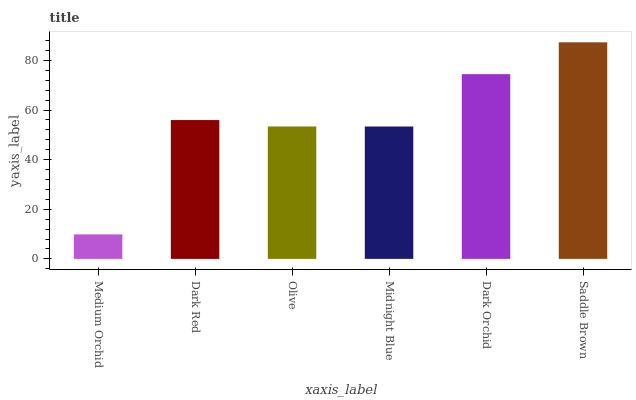Is Medium Orchid the minimum?
Answer yes or no. Yes. Is Saddle Brown the maximum?
Answer yes or no. Yes. Is Dark Red the minimum?
Answer yes or no. No. Is Dark Red the maximum?
Answer yes or no. No. Is Dark Red greater than Medium Orchid?
Answer yes or no. Yes. Is Medium Orchid less than Dark Red?
Answer yes or no. Yes. Is Medium Orchid greater than Dark Red?
Answer yes or no. No. Is Dark Red less than Medium Orchid?
Answer yes or no. No. Is Dark Red the high median?
Answer yes or no. Yes. Is Olive the low median?
Answer yes or no. Yes. Is Midnight Blue the high median?
Answer yes or no. No. Is Midnight Blue the low median?
Answer yes or no. No. 